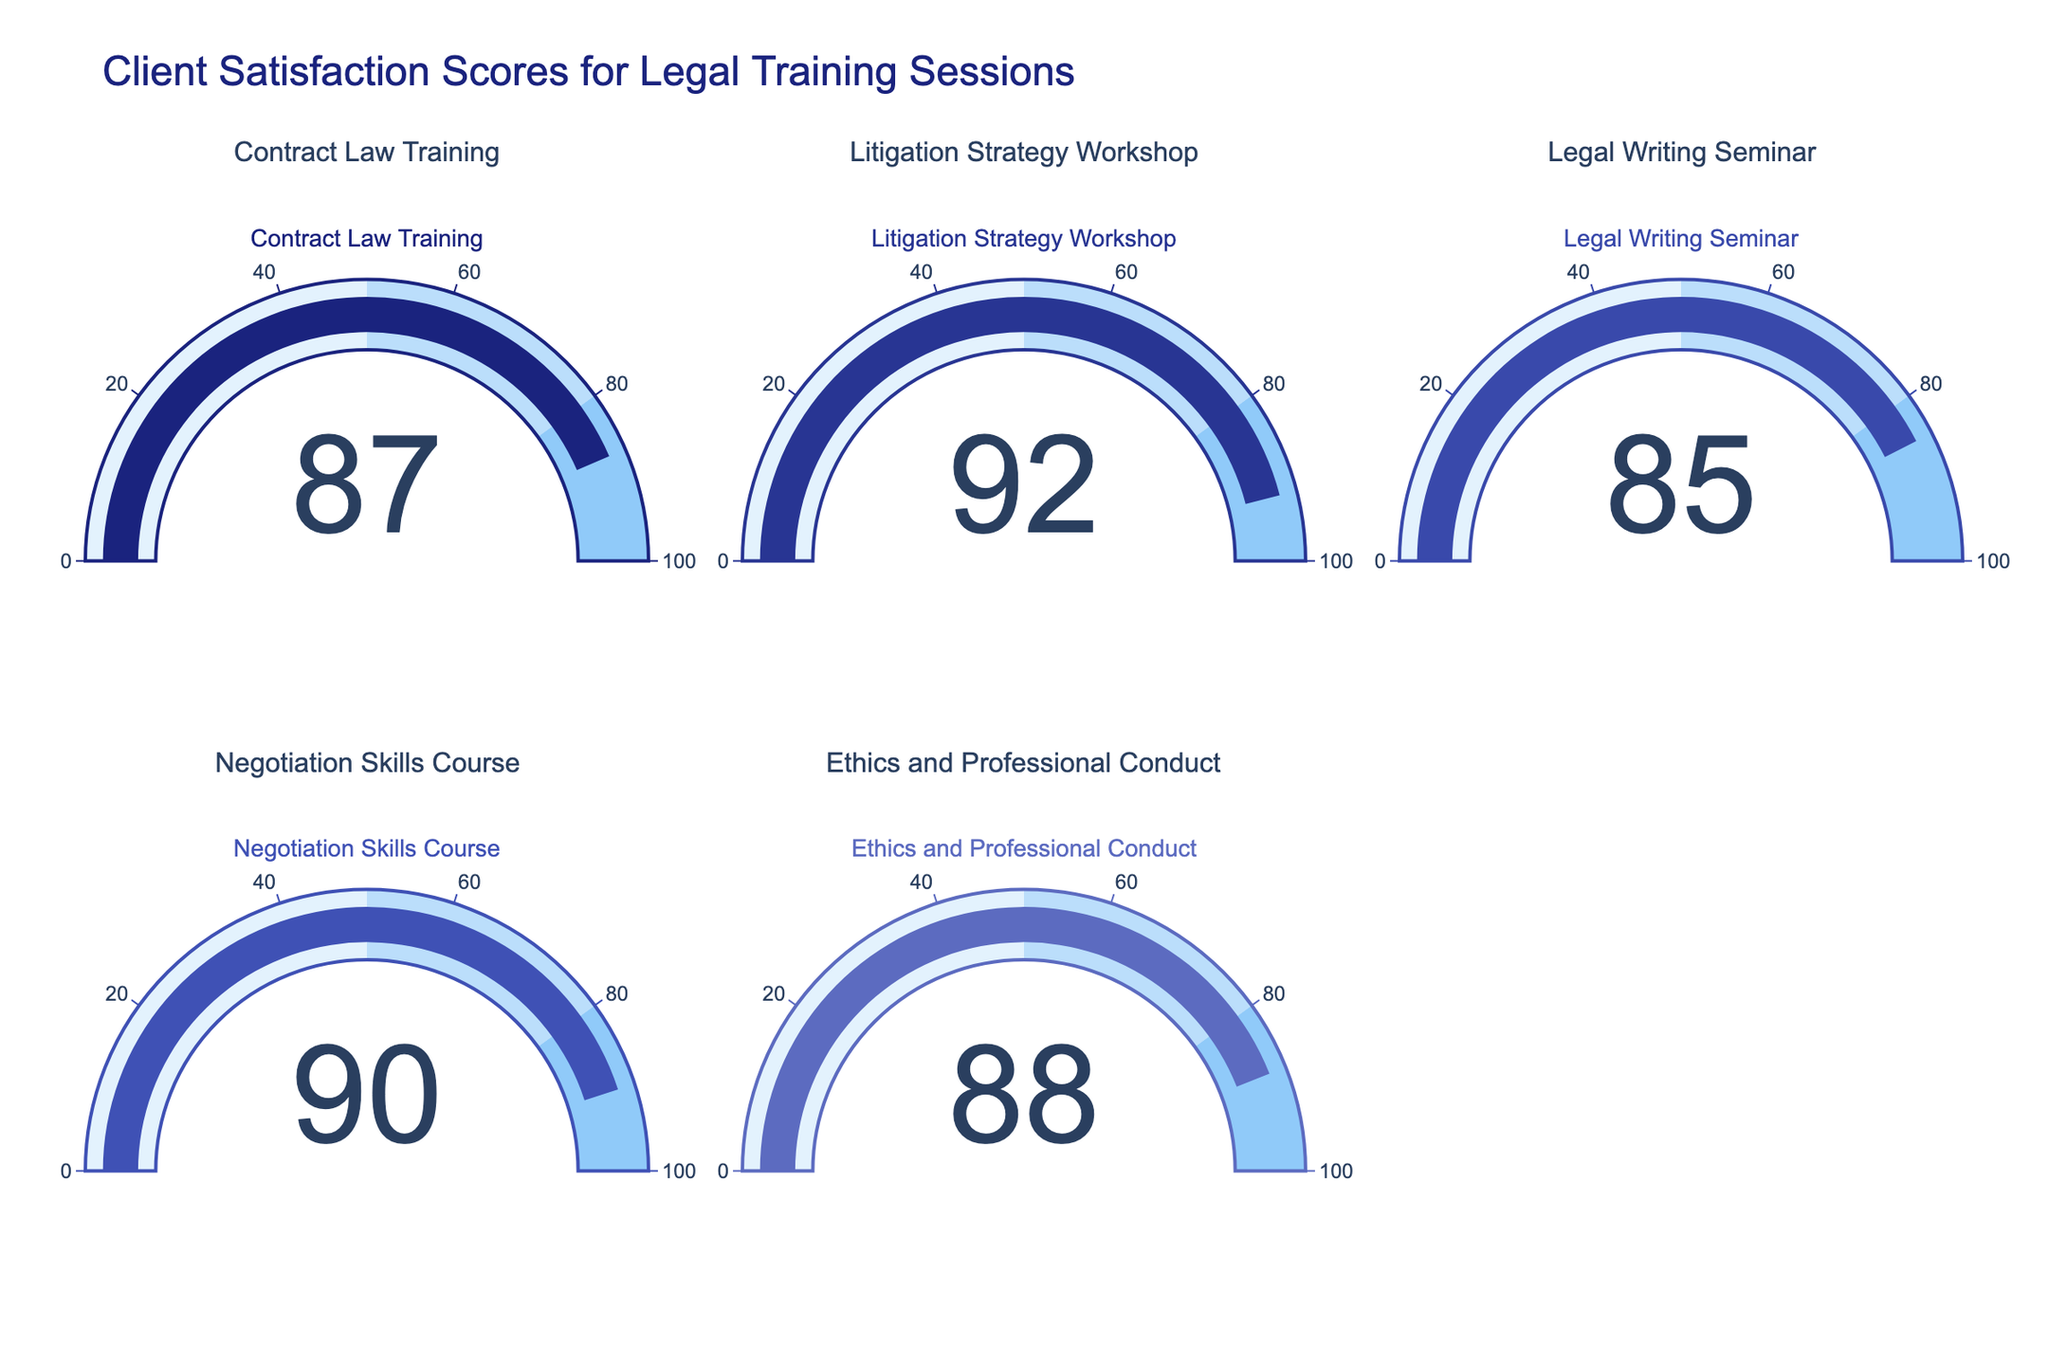What training session has the highest client satisfaction score? By looking at the gauge displaying the "Litigation Strategy Workshop", we can see its score is 92, which is the highest among all the scores represented in the figure.
Answer: Litigation Strategy Workshop Which training session category has the lowest client satisfaction score and what is the score? By observing the gauge charts, the "Legal Writing Seminar" shows the lowest score with a value of 85.
Answer: Legal Writing Seminar with 85 What is the average client satisfaction score across all training sessions? To compute the average score: \[(87 + 92 + 85 + 90 + 88) / 5 = 88.4\]
Answer: 88.4 How much higher is the satisfaction score for "Litigation Strategy Workshop" compared to "Legal Writing Seminar"? Subtract the satisfaction score of "Legal Writing Seminar" from the score of "Litigation Strategy Workshop": \(92 - 85 = 7\)
Answer: 7 Does any training session have a client satisfaction score below 80? By examining the gauges, none of the scores fall below 80. The lowest score is 85.
Answer: No What is the range of client satisfaction scores displayed? The range can be calculated by subtracting the lowest score from the highest score: \(92 - 85 = 7\)
Answer: 7 Which training sessions have satisfaction scores above 90? From the gauges, we can see that "Litigation Strategy Workshop" and "Negotiation Skills Course" have scores of 92 and 90 respectively. However, only "Litigation Strategy Workshop" exceeds 90.
Answer: Litigation Strategy Workshop How does the "Negotiation Skills Course" score compare to the "Ethics and Professional Conduct" score? The "Negotiation Skills Course" has a score of 90 while the "Ethics and Professional Conduct" has a score of 88. By comparing these scores, we see that 90 is greater than 88.
Answer: Negotiation Skills Course is higher What is the difference in scores between "Contract Law Training" and "Ethics and Professional Conduct"? Calculate the difference by subtracting the "Ethics and Professional Conduct" score from the "Contract Law Training" score: \(87 - 88 = -1\)
Answer: -1 What percentage of the training sessions have scores above 85? There are 5 training sessions in total. The number of sessions scoring above 85 are 4 (87, 92, 90, and 88), thus the percentage is \[(4 / 5) * 100 = 80%\]
Answer: 80% 